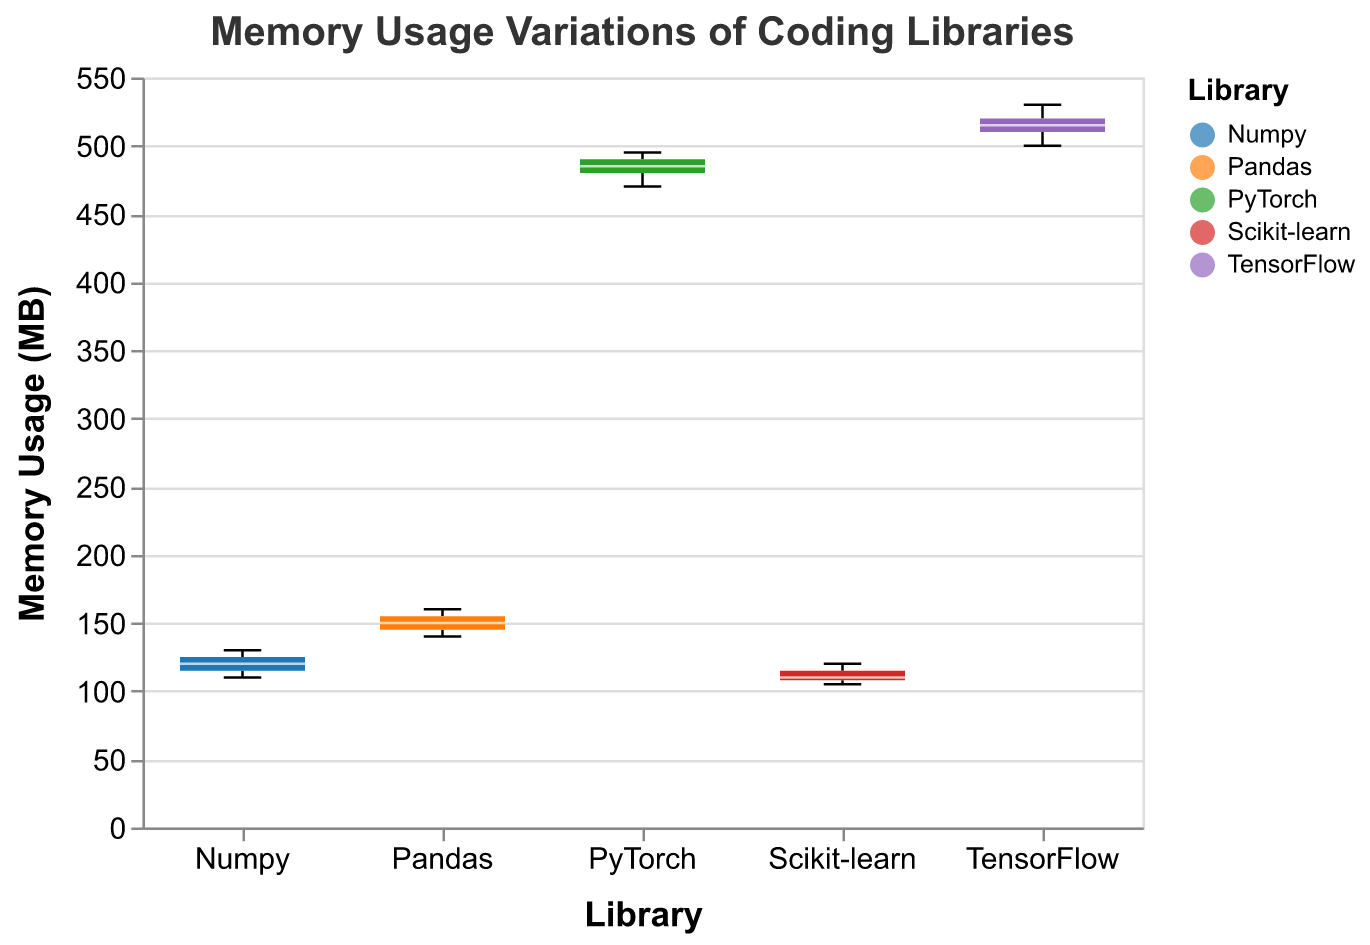What's the title of the figure? The title is displayed at the top of the figure, indicating what the plot represents: "Memory Usage Variations of Coding Libraries".
Answer: Memory Usage Variations of Coding Libraries How many libraries are compared in the figure? Each library is represented by a separate box in the box plot, with distinct colors. By counting these boxes, we identify that five libraries are compared: Numpy, Pandas, Scikit-learn, TensorFlow, and PyTorch.
Answer: 5 Which library has the highest median memory usage? To determine the highest median, observe the middle line (usually white or a different color) inside each box. The median for TensorFlow is the highest, as its line is positioned at a higher memory usage compared to other libraries.
Answer: TensorFlow What is the range of memory usage for Pandas? The range can be found by identifying the minimum and maximum lines extending from the box (whiskers). For Pandas, these extend from approximately 140 MB to 160 MB, giving a range of roughly 20 MB.
Answer: 20 MB Which library shows the widest spread in memory usage? The spread is indicated by the height of the box and the length of the whiskers. TensorFlow has the widest spread because its box and whiskers cover a larger range, extending from about 500 MB to 530 MB.
Answer: TensorFlow Compare the maximum memory usage of Numpy and Scikit-learn. Which one is higher? Look at the top whiskers of the boxes for Numpy and Scikit-learn. Numpy's highest point is around 130 MB, while Scikit-learn's is around 120 MB. Therefore, Numpy has the higher maximum memory usage.
Answer: Numpy What is the interquartile range (IQR) of PyTorch’s memory usage? The IQR is the range between the first quartile (25th percentile) and the third quartile (75th percentile) within the box. For PyTorch, the box extends from approximately 470 MB to 490 MB, resulting in an IQR of 20 MB.
Answer: 20 MB Which library has the smallest variation in memory usage? Variation is indicated by the size of the box and the length of the whiskers. Scikit-learn shows the smallest variation, with its box and whiskers covering a smaller range compared to the others.
Answer: Scikit-learn What is the median memory usage for Numpy? The median is represented by the line (usually white or a different color) inside the box. For Numpy, this line is nearly at 120 MB.
Answer: 120 MB Compare the third quartile values of TensorFlow and PyTorch; which one is higher? The third quartile is the top edge of the box. For TensorFlow, it is about 520 MB, whereas for PyTorch, it is around 490 MB. Thus, TensorFlow has a higher third quartile value.
Answer: TensorFlow 